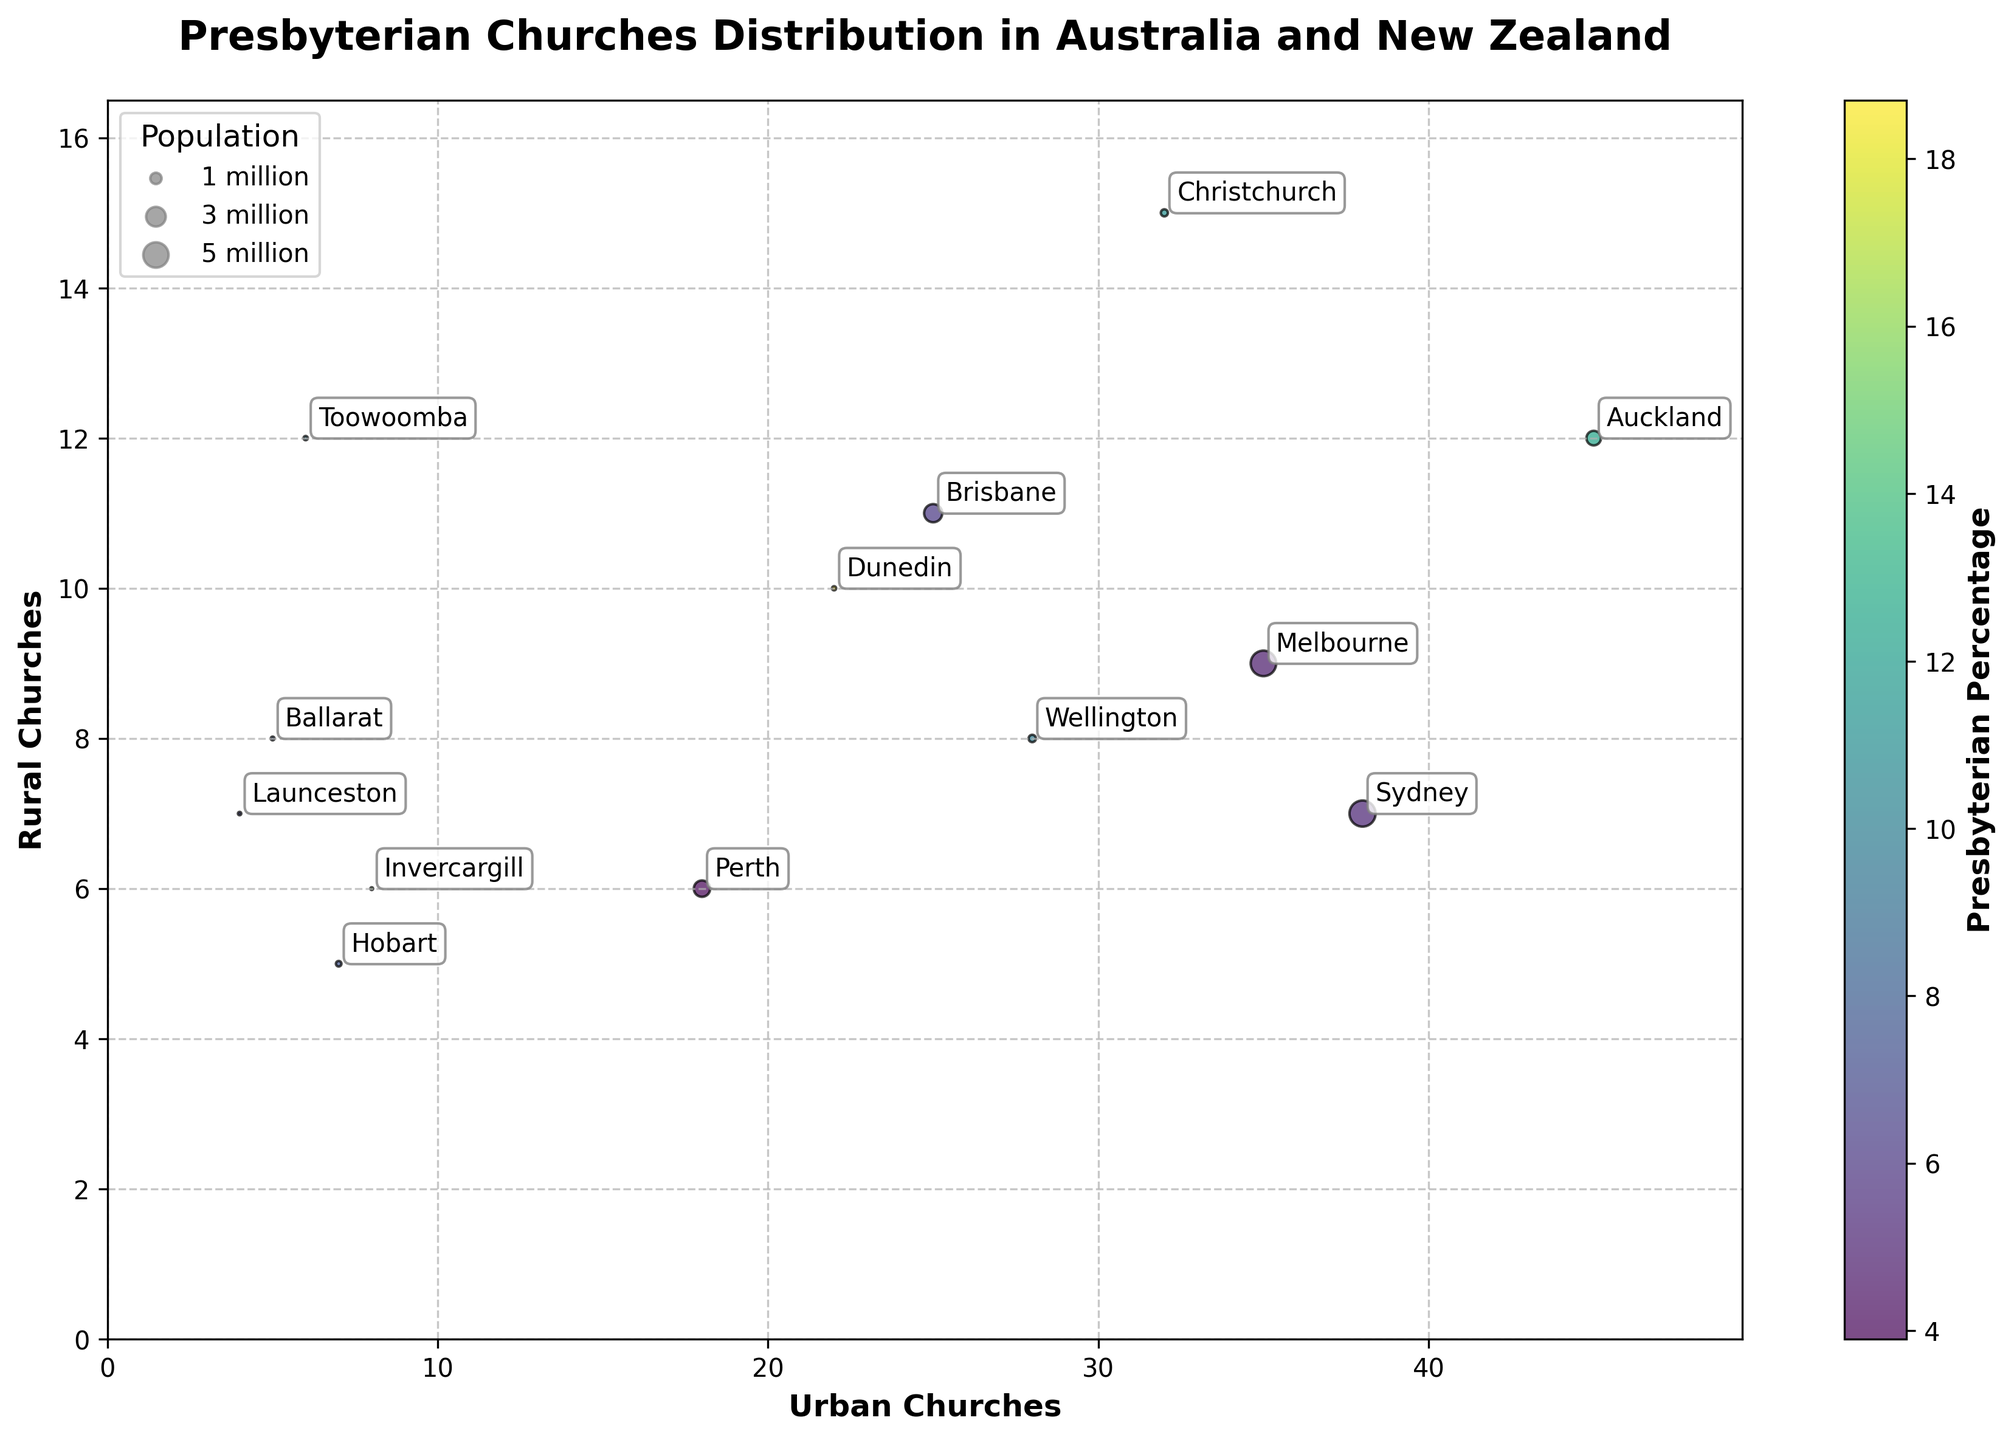How many urban churches are there in Auckland? To find the number of urban churches in Auckland, look at the "Urban Churches" axis for the data point labeled "Auckland".
Answer: 45 Which region has the highest percentage of Presbyterians? To determine the region with the highest percentage of Presbyterians, refer to the color-coded regions and the color bar indicating percentages. The darkest color corresponds to the highest percentage.
Answer: Dunedin What is the combined number of rural churches in Christchurch and Dunedin? To find the combined number of rural churches in Christchurch and Dunedin, locate these regions and add the number of rural churches for each. Christchurch has 15 rural churches, and Dunedin has 10 rural churches. The combined total is 15 + 10.
Answer: 25 Which city has a larger population: Sydney or Melbourne? Compare the sizes of the bubble markers for Sydney and Melbourne, as the marker size represents population. The larger marker corresponds to the larger population. Sydney has a larger marker.
Answer: Sydney What is the total number of churches (urban and rural) in Wellington? To find the total number of churches in Wellington, add the number of urban churches (28) to the number of rural churches (8). The total is 28 + 8.
Answer: 36 Which city has a higher concentration of rural churches, Ballarat or Toowoomba? Compare the positions of Ballarat and Toowoomba on the "Rural Churches" axis. The label positioned higher on this axis has more rural churches. Toowoomba has a higher count at 12.
Answer: Toowoomba How many regions have more than 30 urban churches? Identify data points where the number of urban churches exceeds 30 by looking at the "Urban Churches" axis. Auckland, Christchurch, Sydney, and Melbourne meet this criterion.
Answer: 4 In which city is the proportion of Presbyterians highest relative to its population? Analyze the color intensity for each region, which indicates the Presbyterian percentage. The darkest shaded data point represents the highest proportion. Dunedin has the darkest shade.
Answer: Dunedin 